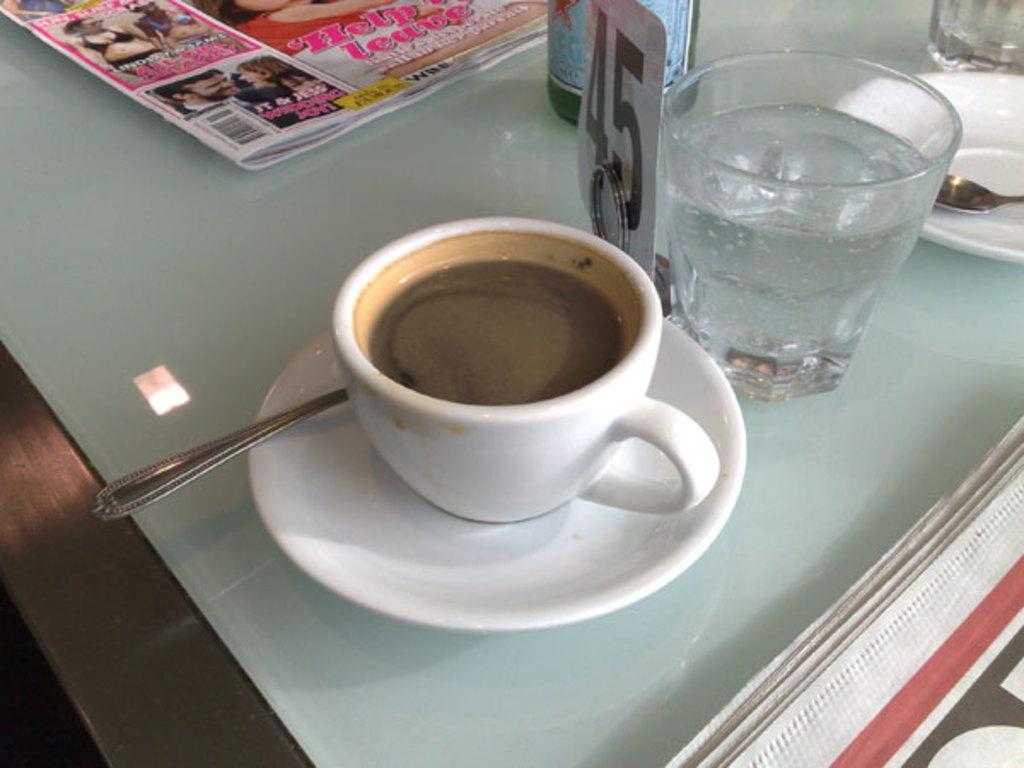How would you summarize this image in a sentence or two? This picture is taken over a dining table. In the center of the picture there is a cup with some drink, beside it there is a glass. And in the background there is a bottle and a newspaper. And on the right there is a plate and a spoon. 